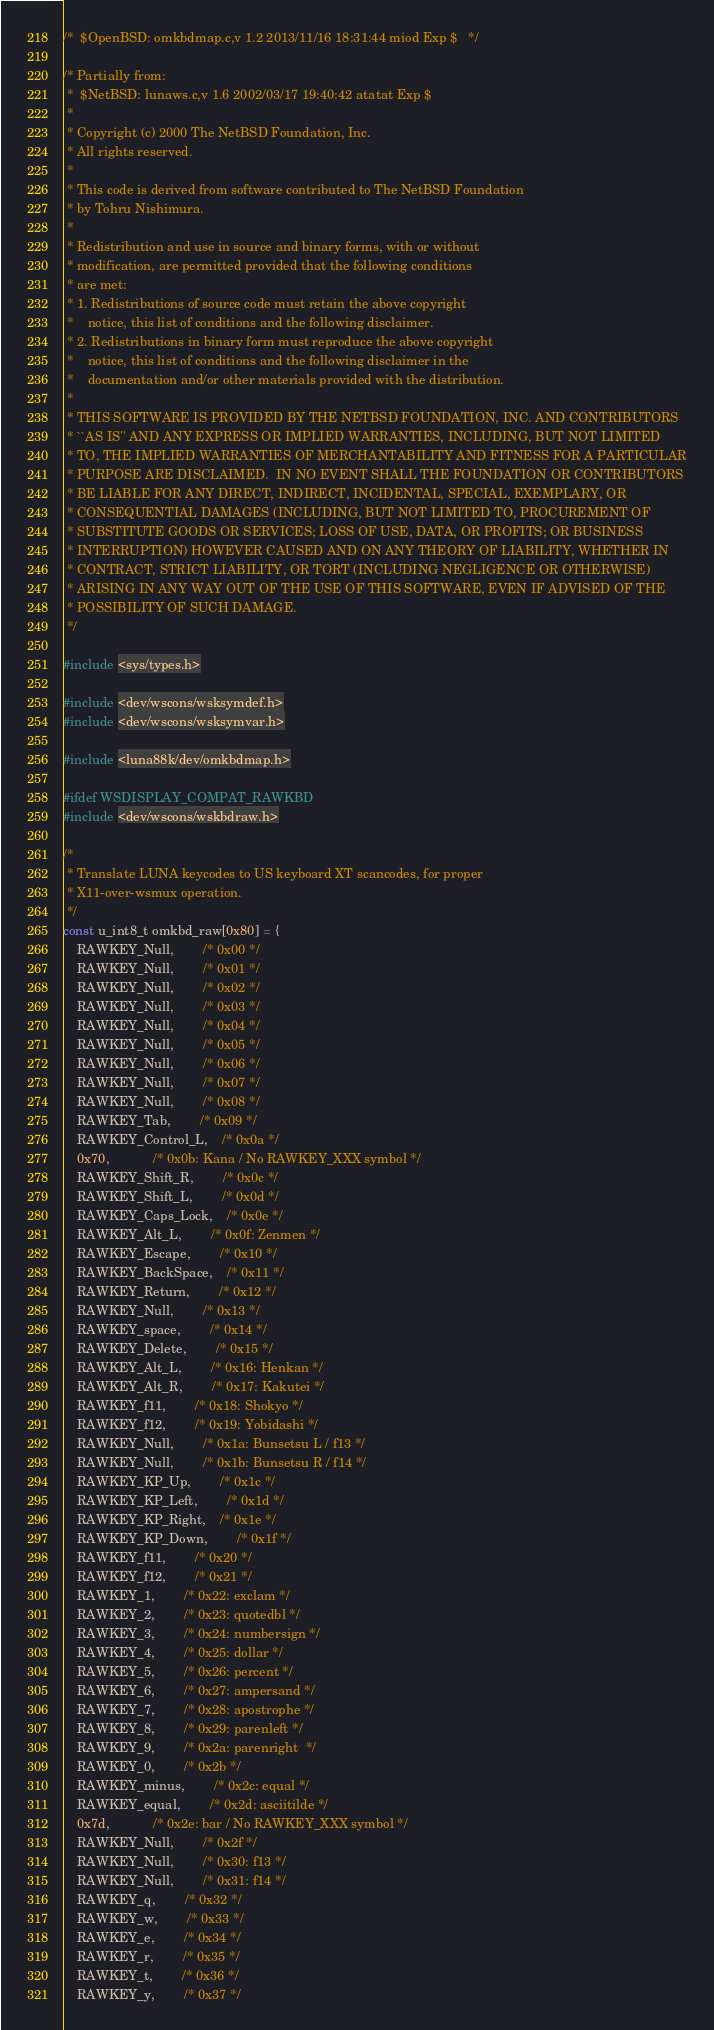<code> <loc_0><loc_0><loc_500><loc_500><_C_>/*	$OpenBSD: omkbdmap.c,v 1.2 2013/11/16 18:31:44 miod Exp $	*/

/* Partially from:
 *	$NetBSD: lunaws.c,v 1.6 2002/03/17 19:40:42 atatat Exp $
 *
 * Copyright (c) 2000 The NetBSD Foundation, Inc.
 * All rights reserved.
 *
 * This code is derived from software contributed to The NetBSD Foundation
 * by Tohru Nishimura.
 *
 * Redistribution and use in source and binary forms, with or without
 * modification, are permitted provided that the following conditions
 * are met:
 * 1. Redistributions of source code must retain the above copyright
 *    notice, this list of conditions and the following disclaimer.
 * 2. Redistributions in binary form must reproduce the above copyright
 *    notice, this list of conditions and the following disclaimer in the
 *    documentation and/or other materials provided with the distribution.
 *
 * THIS SOFTWARE IS PROVIDED BY THE NETBSD FOUNDATION, INC. AND CONTRIBUTORS
 * ``AS IS'' AND ANY EXPRESS OR IMPLIED WARRANTIES, INCLUDING, BUT NOT LIMITED
 * TO, THE IMPLIED WARRANTIES OF MERCHANTABILITY AND FITNESS FOR A PARTICULAR
 * PURPOSE ARE DISCLAIMED.  IN NO EVENT SHALL THE FOUNDATION OR CONTRIBUTORS
 * BE LIABLE FOR ANY DIRECT, INDIRECT, INCIDENTAL, SPECIAL, EXEMPLARY, OR
 * CONSEQUENTIAL DAMAGES (INCLUDING, BUT NOT LIMITED TO, PROCUREMENT OF
 * SUBSTITUTE GOODS OR SERVICES; LOSS OF USE, DATA, OR PROFITS; OR BUSINESS
 * INTERRUPTION) HOWEVER CAUSED AND ON ANY THEORY OF LIABILITY, WHETHER IN
 * CONTRACT, STRICT LIABILITY, OR TORT (INCLUDING NEGLIGENCE OR OTHERWISE)
 * ARISING IN ANY WAY OUT OF THE USE OF THIS SOFTWARE, EVEN IF ADVISED OF THE
 * POSSIBILITY OF SUCH DAMAGE.
 */

#include <sys/types.h>

#include <dev/wscons/wsksymdef.h>
#include <dev/wscons/wsksymvar.h>

#include <luna88k/dev/omkbdmap.h>

#ifdef WSDISPLAY_COMPAT_RAWKBD
#include <dev/wscons/wskbdraw.h>

/*
 * Translate LUNA keycodes to US keyboard XT scancodes, for proper
 * X11-over-wsmux operation.
 */
const u_int8_t omkbd_raw[0x80] = {
	RAWKEY_Null,		/* 0x00 */
	RAWKEY_Null,		/* 0x01 */
	RAWKEY_Null,		/* 0x02 */
	RAWKEY_Null,		/* 0x03 */
	RAWKEY_Null,		/* 0x04 */
	RAWKEY_Null,		/* 0x05 */
	RAWKEY_Null,		/* 0x06 */
	RAWKEY_Null,		/* 0x07 */
	RAWKEY_Null,		/* 0x08 */
	RAWKEY_Tab,		/* 0x09 */
	RAWKEY_Control_L,	/* 0x0a */
	0x70,			/* 0x0b: Kana / No RAWKEY_XXX symbol */
	RAWKEY_Shift_R,		/* 0x0c */
	RAWKEY_Shift_L,		/* 0x0d */
	RAWKEY_Caps_Lock,	/* 0x0e */
	RAWKEY_Alt_L,		/* 0x0f: Zenmen */
	RAWKEY_Escape,		/* 0x10 */
	RAWKEY_BackSpace,	/* 0x11 */
	RAWKEY_Return,		/* 0x12 */
	RAWKEY_Null,		/* 0x13 */
	RAWKEY_space,		/* 0x14 */
	RAWKEY_Delete,		/* 0x15 */
	RAWKEY_Alt_L,		/* 0x16: Henkan */
	RAWKEY_Alt_R,		/* 0x17: Kakutei */
	RAWKEY_f11,		/* 0x18: Shokyo */
	RAWKEY_f12,		/* 0x19: Yobidashi */
	RAWKEY_Null,		/* 0x1a: Bunsetsu L / f13 */
	RAWKEY_Null,		/* 0x1b: Bunsetsu R / f14 */
	RAWKEY_KP_Up,		/* 0x1c */
	RAWKEY_KP_Left,		/* 0x1d */
	RAWKEY_KP_Right,	/* 0x1e */
	RAWKEY_KP_Down,		/* 0x1f */
	RAWKEY_f11,		/* 0x20 */
	RAWKEY_f12,		/* 0x21 */
	RAWKEY_1,		/* 0x22: exclam */
	RAWKEY_2,		/* 0x23: quotedbl */
	RAWKEY_3,		/* 0x24: numbersign */
	RAWKEY_4,		/* 0x25: dollar */
	RAWKEY_5,		/* 0x26: percent */
	RAWKEY_6,		/* 0x27: ampersand */
	RAWKEY_7,		/* 0x28: apostrophe */
	RAWKEY_8,		/* 0x29: parenleft */
	RAWKEY_9,		/* 0x2a: parenright  */
	RAWKEY_0,		/* 0x2b */
	RAWKEY_minus,		/* 0x2c: equal */
	RAWKEY_equal,		/* 0x2d: asciitilde */
	0x7d,			/* 0x2e: bar / No RAWKEY_XXX symbol */
	RAWKEY_Null, 		/* 0x2f */
	RAWKEY_Null, 		/* 0x30: f13 */
	RAWKEY_Null, 		/* 0x31: f14 */
	RAWKEY_q,		/* 0x32 */
	RAWKEY_w,		/* 0x33 */
	RAWKEY_e,		/* 0x34 */
	RAWKEY_r,		/* 0x35 */
	RAWKEY_t,		/* 0x36 */
	RAWKEY_y,		/* 0x37 */</code> 